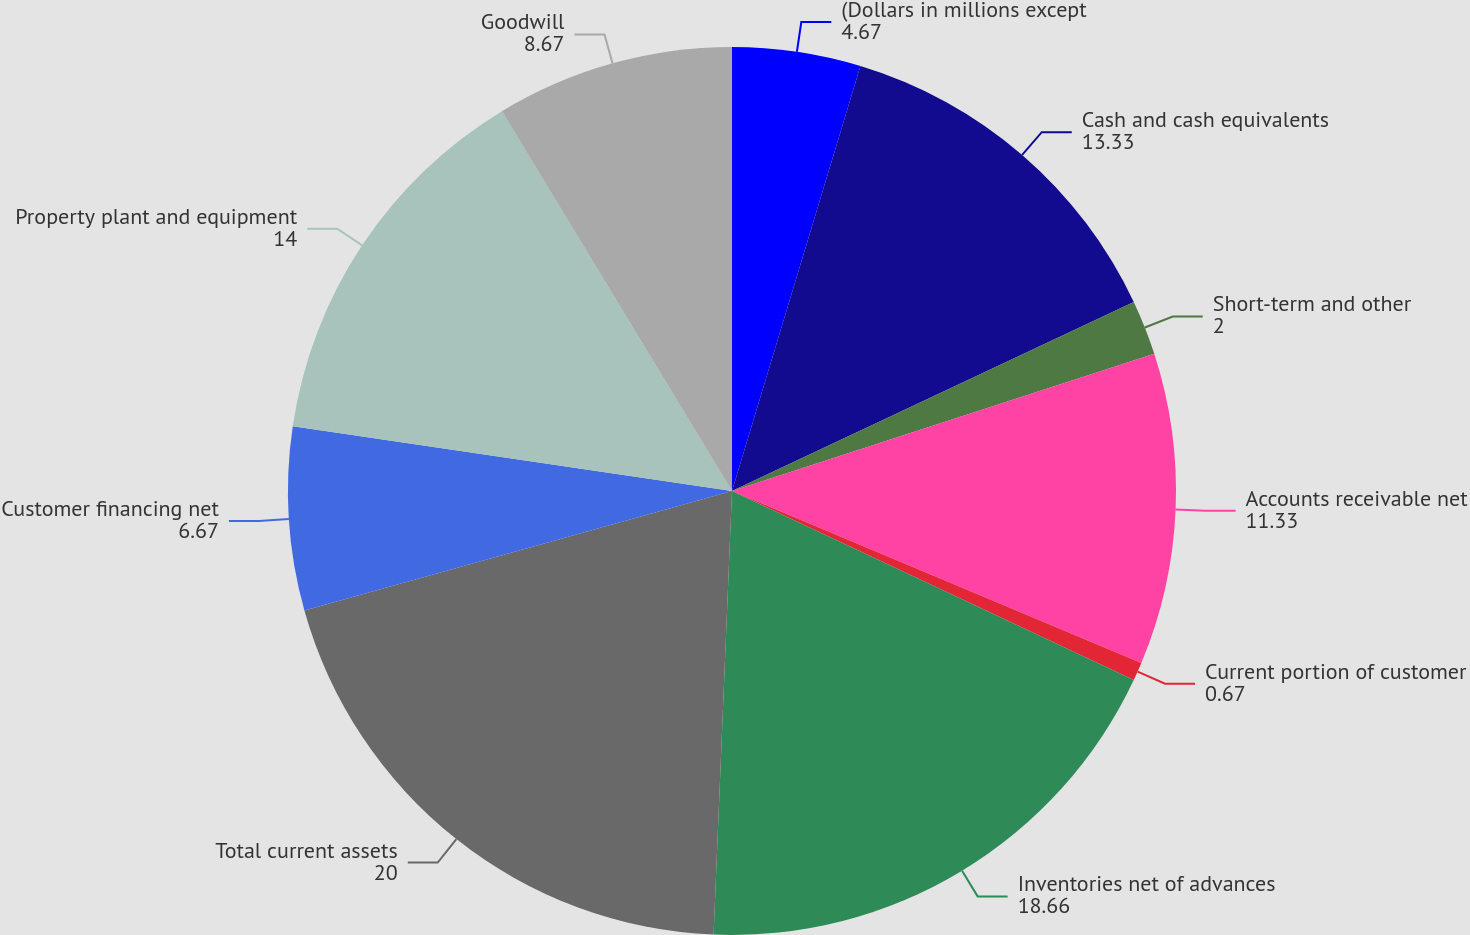Convert chart to OTSL. <chart><loc_0><loc_0><loc_500><loc_500><pie_chart><fcel>(Dollars in millions except<fcel>Cash and cash equivalents<fcel>Short-term and other<fcel>Accounts receivable net<fcel>Current portion of customer<fcel>Inventories net of advances<fcel>Total current assets<fcel>Customer financing net<fcel>Property plant and equipment<fcel>Goodwill<nl><fcel>4.67%<fcel>13.33%<fcel>2.0%<fcel>11.33%<fcel>0.67%<fcel>18.66%<fcel>20.0%<fcel>6.67%<fcel>14.0%<fcel>8.67%<nl></chart> 